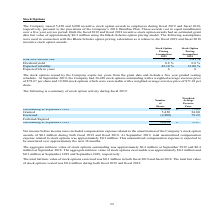From Amcon Distributing's financial document, What is the compensation expense related to the amortization of the Company’s stock option awards included in the net income before income taxes in both fiscal 2018 and 2019 respectively? The document shows two values: $0.1 million and $0.1 million. From the document: "ortization of the Company’s stock option awards of $0.1 million during both fiscal 2019 and fiscal 2018. At September 2019, total unamortized compensa..." Also, What are the aggregate intrinsic value of stock options exercisable at September 2018 and 2019 respectively? The document shows two values: $0.3 million and $0.2 million. From the document: "n estimated grant date fair value of approximately $0.2 million using the Black-Scholes option pricing model. The following assumptions were used in c..." Also, What is the respective total intrinsic value of stock options exercised in 2018 and 2019? The document shows two values: $0.1 million and $0.1 million. From the document: "ortization of the Company’s stock option awards of $0.1 million during both fiscal 2019 and fiscal 2018. At September 2019, total unamortized compensa..." Also, can you calculate: What is the percentage change in the company's shares outstanding at September 2018 and 2019? To answer this question, I need to perform calculations using the financial data. The calculation is: (36,450 - 33,800)/33,800 , which equals 7.84 (percentage). This is based on the information: "Outstanding at September 2019 36,450 $ 78.67 Outstanding at September 2018 33,800 $ 77.85..." The key data points involved are: 33,800, 36,450. Also, can you calculate: What is the percentage of shares granted as a percentage of the number of outstanding shares at 2018? Based on the calculation: 5,450/33,800 , the result is 16.12 (percentage). This is based on the information: "Granted 5,450 84.00 Outstanding at September 2018 33,800 $ 77.85..." The key data points involved are: 33,800, 5,450. Also, can you calculate: What is the difference in the total number of shares outstanding between 2018 and 2019? Based on the calculation: 36,450-33,800 , the result is 2650. This is based on the information: "Outstanding at September 2019 36,450 $ 78.67 Outstanding at September 2018 33,800 $ 77.85..." The key data points involved are: 33,800, 36,450. 